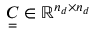Convert formula to latex. <formula><loc_0><loc_0><loc_500><loc_500>\underset { = } { C } \in \mathbb { R } ^ { n _ { d } \times n _ { d } }</formula> 